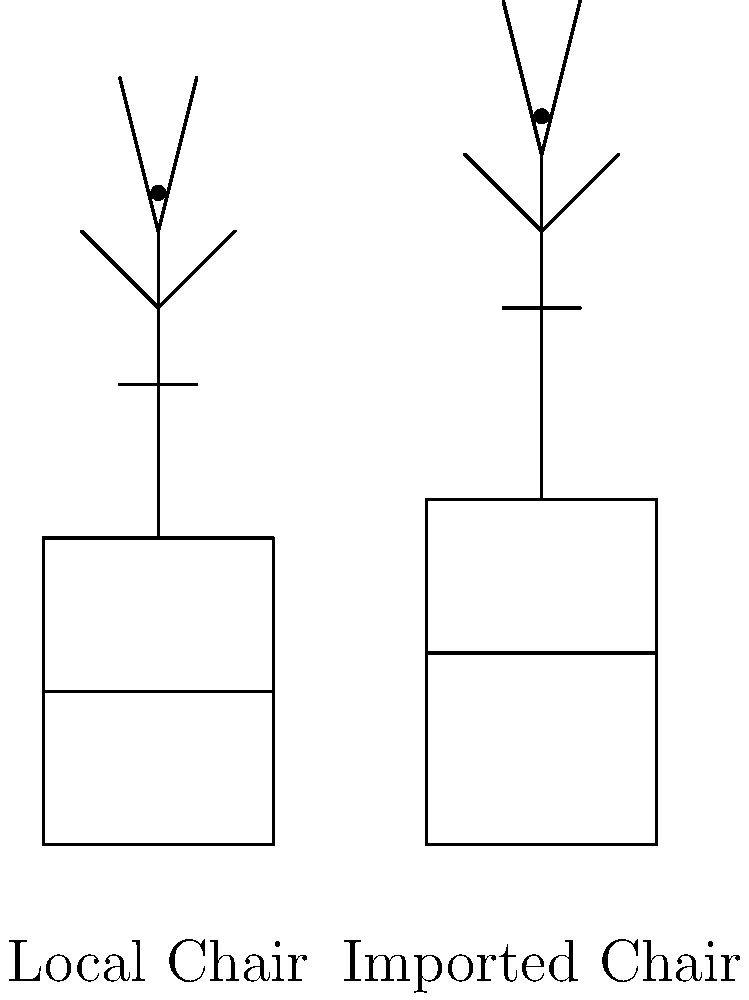Based on the stick figure diagrams comparing a local office chair and an imported office chair, which chair appears to have better ergonomics for prolonged sitting, and why? To determine which chair has better ergonomics for prolonged sitting, we need to analyze the diagrams and consider key ergonomic factors:

1. Seat height:
   - Local chair: The seat is lower, with the user's knees bent at approximately 90 degrees.
   - Imported chair: The seat is slightly higher, allowing for a more open hip angle.

2. Backrest height:
   - Local chair: The backrest is shorter, providing less upper back support.
   - Imported chair: The backrest is taller, offering better support for the entire back.

3. Seat depth:
   - Local chair: The seat appears shallower, which may not provide adequate thigh support.
   - Imported chair: The seat seems deeper, potentially offering better thigh support and weight distribution.

4. Lumbar support:
   - Local chair: There's no visible lumbar support.
   - Imported chair: The backrest curve suggests built-in lumbar support.

5. User posture:
   - Local chair: The user's posture is more hunched, with increased spinal flexion.
   - Imported chair: The user's posture is more upright, promoting better spinal alignment.

6. Armrests:
   - Neither chair shows armrests, but the imported chair's higher seat might allow for better arm positioning if a desk is used.

Considering these factors, the imported chair appears to have better ergonomics for prolonged sitting. It promotes a more neutral spine position, provides better back support, and allows for a more open hip angle, which can reduce pressure on the lower back and improve overall comfort during extended periods of use.
Answer: Imported chair; better back support, seat depth, and promotes improved posture. 